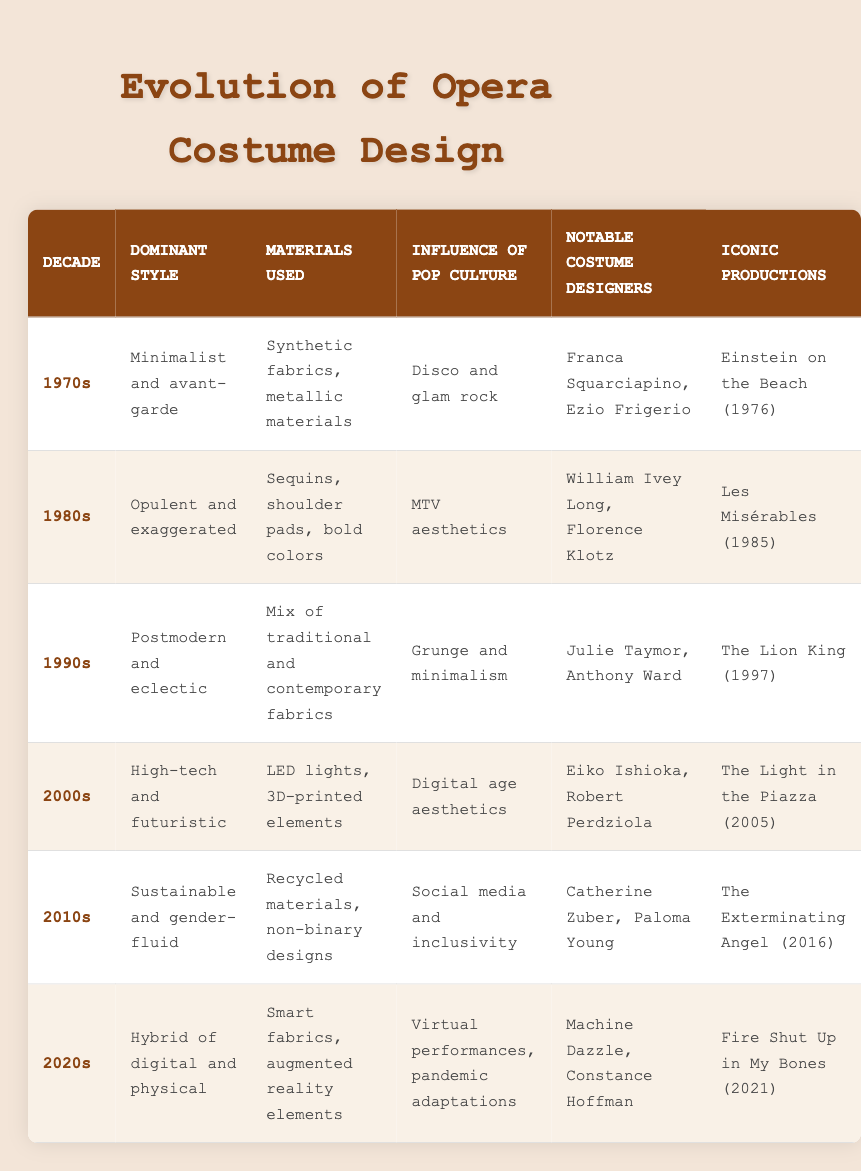What was the dominant style of the 1980s? The table lists the dominant style for the 1980s as "Opulent and exaggerated."
Answer: Opulent and exaggerated Which materials were commonly used in the 1970s costumes? According to the table, the materials used in the 1970s were "Synthetic fabrics, metallic materials."
Answer: Synthetic fabrics, metallic materials Was Julie Taymor a noted costume designer in the 1990s? Yes, the table indicates that Julie Taymor was a notable costume designer during the 1990s.
Answer: Yes What influence of pop culture did the costumes in the 2000s draw from? The table states that the influence of pop culture during the 2000s was "Digital age aesthetics."
Answer: Digital age aesthetics How many different dominant styles are listed from the 1970s to 2020s? The table lists six decades, each with a unique dominant style: Minimalist and avant-garde, Opulent and exaggerated, Postmodern and eclectic, High-tech and futuristic, Sustainable and gender-fluid, and Hybrid of digital and physical, totaling six styles.
Answer: Six styles What notable production is associated with Franca Squarciapino? The notable production associated with Franca Squarciapino from the table is "Einstein on the Beach (1976)."
Answer: Einstein on the Beach (1976) Did any decade feature costumes made with LED lights? Yes, the table shows that the 2000s featured costumes made with LED lights.
Answer: Yes In which decade did costumes utilize recycled materials? The table indicates that costumes utilizing recycled materials were featured in the 2010s.
Answer: 2010s Which decade's costumes were influenced by disco and glam rock? The table clearly states that disco and glam rock influenced the costumes of the 1970s.
Answer: 1970s 